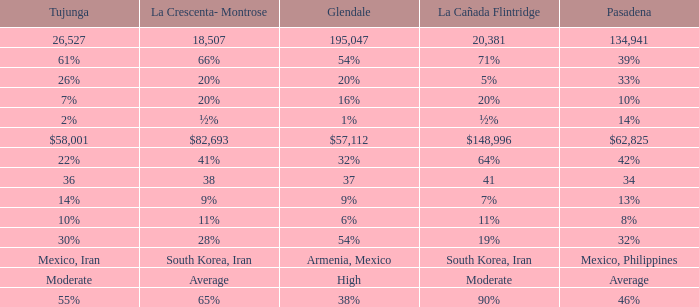If pasadena is at a 10% level, what level is la crescenta-montrose at? 20%. Parse the full table. {'header': ['Tujunga', 'La Crescenta- Montrose', 'Glendale', 'La Cañada Flintridge', 'Pasadena'], 'rows': [['26,527', '18,507', '195,047', '20,381', '134,941'], ['61%', '66%', '54%', '71%', '39%'], ['26%', '20%', '20%', '5%', '33%'], ['7%', '20%', '16%', '20%', '10%'], ['2%', '½%', '1%', '½%', '14%'], ['$58,001', '$82,693', '$57,112', '$148,996', '$62,825'], ['22%', '41%', '32%', '64%', '42%'], ['36', '38', '37', '41', '34'], ['14%', '9%', '9%', '7%', '13%'], ['10%', '11%', '6%', '11%', '8%'], ['30%', '28%', '54%', '19%', '32%'], ['Mexico, Iran', 'South Korea, Iran', 'Armenia, Mexico', 'South Korea, Iran', 'Mexico, Philippines'], ['Moderate', 'Average', 'High', 'Moderate', 'Average'], ['55%', '65%', '38%', '90%', '46%']]} 